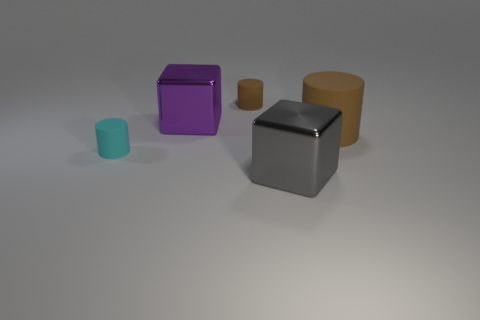Add 1 cyan rubber cylinders. How many objects exist? 6 Subtract all cubes. How many objects are left? 3 Subtract 0 cyan cubes. How many objects are left? 5 Subtract all purple things. Subtract all cylinders. How many objects are left? 1 Add 5 big brown matte objects. How many big brown matte objects are left? 6 Add 2 gray shiny cubes. How many gray shiny cubes exist? 3 